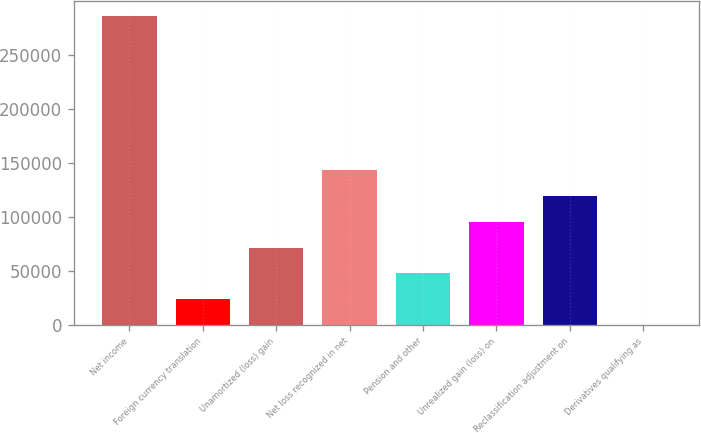Convert chart. <chart><loc_0><loc_0><loc_500><loc_500><bar_chart><fcel>Net income<fcel>Foreign currency translation<fcel>Unamortized (loss) gain<fcel>Net loss recognized in net<fcel>Pension and other<fcel>Unrealized gain (loss) on<fcel>Reclassification adjustment on<fcel>Derivatives qualifying as<nl><fcel>285396<fcel>23844.4<fcel>71399.2<fcel>142731<fcel>47621.8<fcel>95176.6<fcel>118954<fcel>67<nl></chart> 